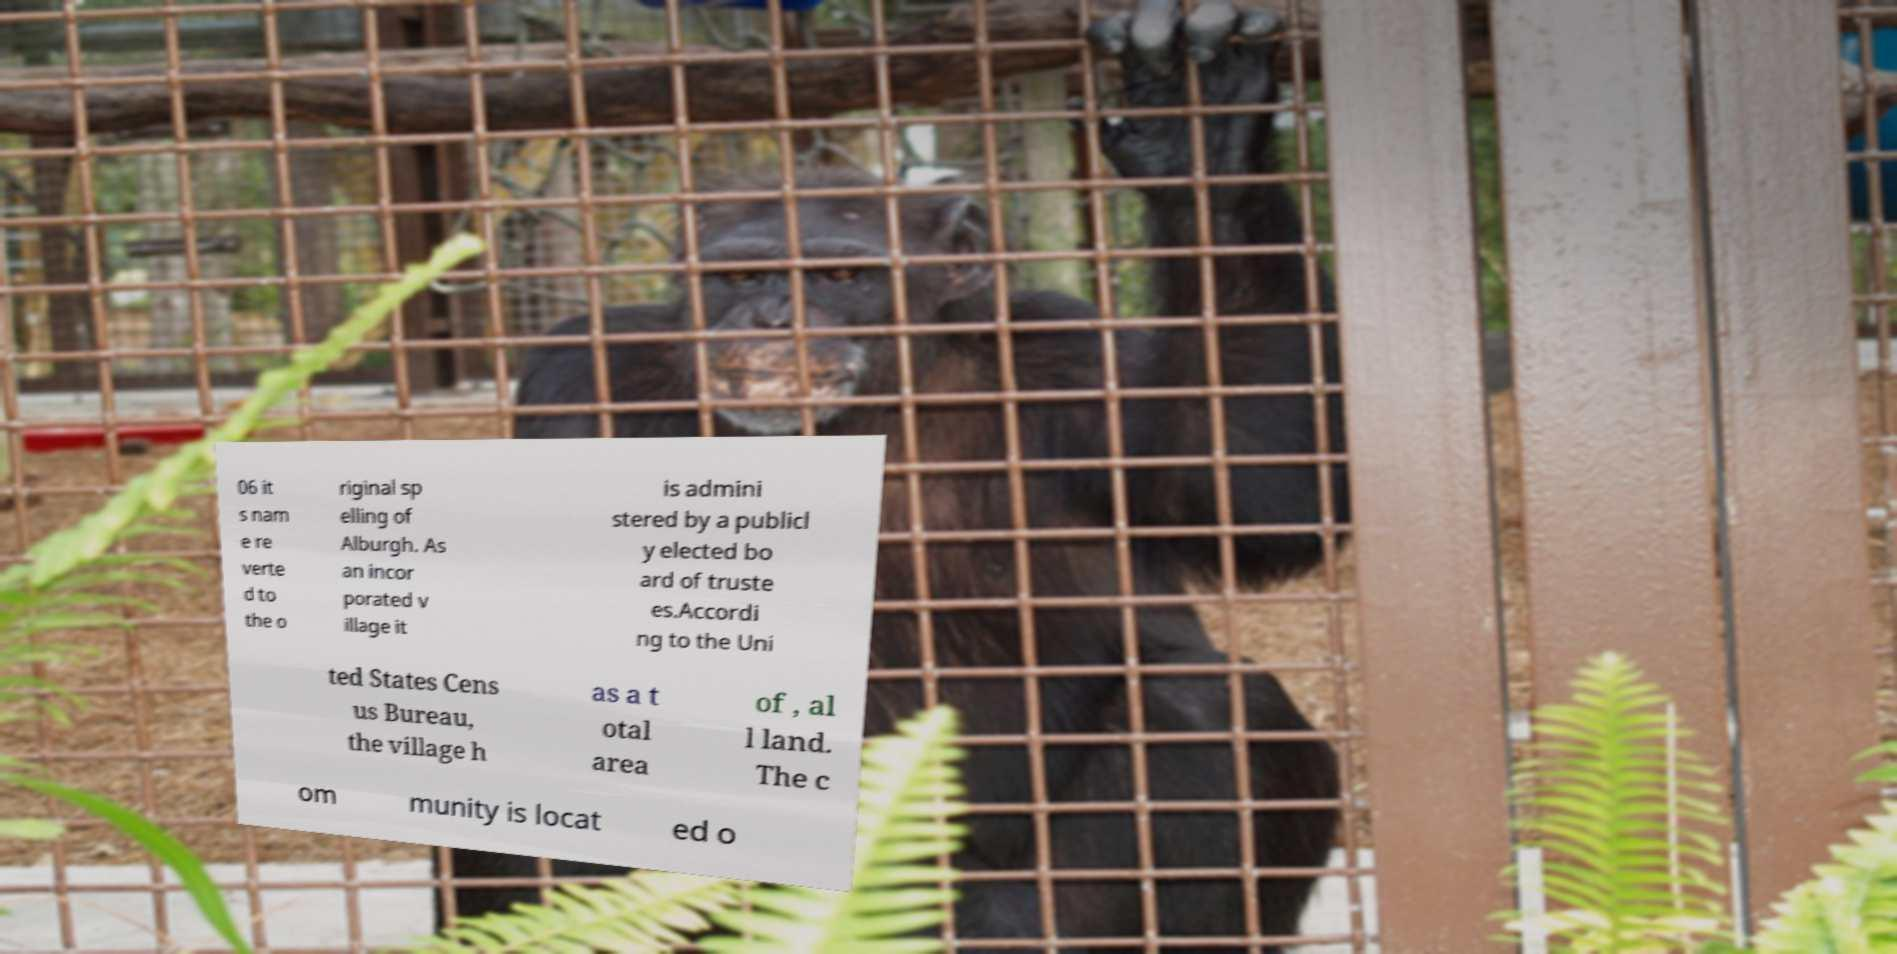Can you read and provide the text displayed in the image?This photo seems to have some interesting text. Can you extract and type it out for me? 06 it s nam e re verte d to the o riginal sp elling of Alburgh. As an incor porated v illage it is admini stered by a publicl y elected bo ard of truste es.Accordi ng to the Uni ted States Cens us Bureau, the village h as a t otal area of , al l land. The c om munity is locat ed o 